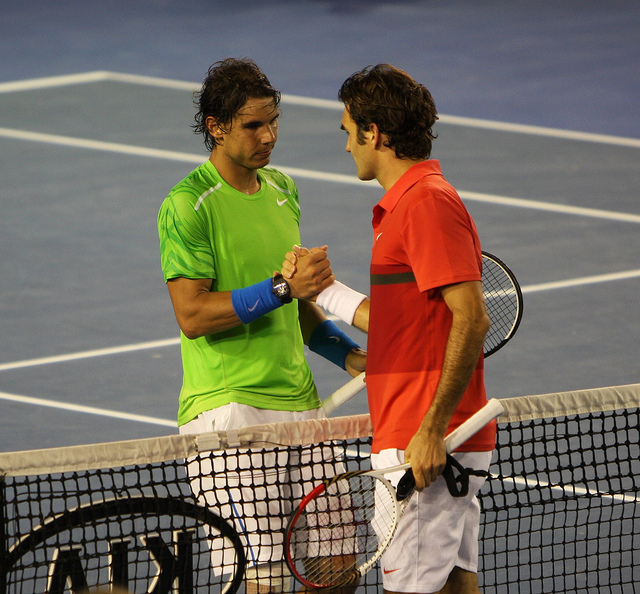<image>Who is wearing a cap? It's ambiguous who is wearing a cap, some answers suggest no one but there's also a suggestion of a man. Who is wearing a cap? No one is wearing a cap. 